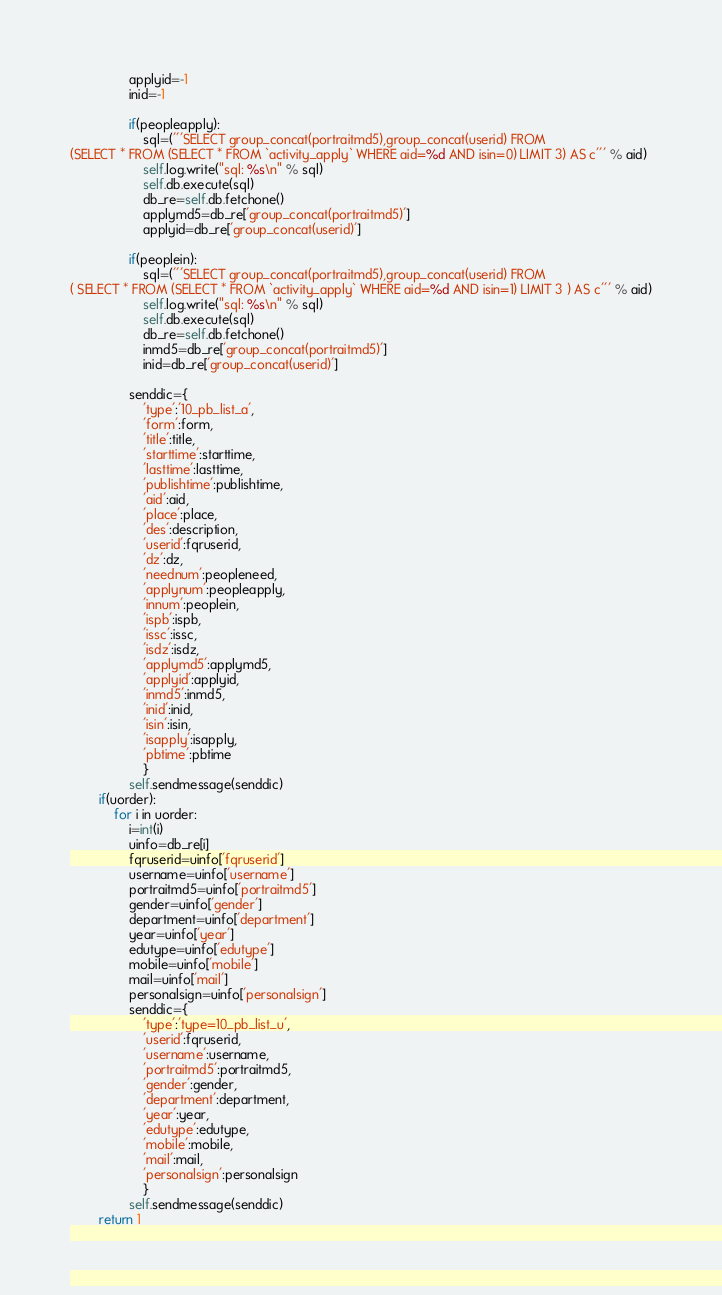Convert code to text. <code><loc_0><loc_0><loc_500><loc_500><_Python_>                applyid=-1
                inid=-1

                if(peopleapply):
                    sql=('''SELECT group_concat(portraitmd5),group_concat(userid) FROM 
(SELECT * FROM (SELECT * FROM `activity_apply` WHERE aid=%d AND isin=0) LIMIT 3) AS c''' % aid)
                    self.log.write("sql: %s\n" % sql)
                    self.db.execute(sql)
                    db_re=self.db.fetchone()
                    applymd5=db_re['group_concat(portraitmd5)']
                    applyid=db_re['group_concat(userid)']

                if(peoplein):
                    sql=('''SELECT group_concat(portraitmd5),group_concat(userid) FROM 
( SELECT * FROM (SELECT * FROM `activity_apply` WHERE aid=%d AND isin=1) LIMIT 3 ) AS c''' % aid)
                    self.log.write("sql: %s\n" % sql)
                    self.db.execute(sql)
                    db_re=self.db.fetchone()
                    inmd5=db_re['group_concat(portraitmd5)']
                    inid=db_re['group_concat(userid)']

                senddic={
                    'type':'10_pb_list_a',
                    'form':form,
                    'title':title,
                    'starttime':starttime,
                    'lasttime':lasttime,
                    'publishtime':publishtime,
                    'aid':aid,
                    'place':place,
                    'des':description,
                    'userid':fqruserid,
                    'dz':dz,
                    'neednum':peopleneed,
                    'applynum':peopleapply,
                    'innum':peoplein,
                    'ispb':ispb,
                    'issc':issc,
                    'isdz':isdz,
                    'applymd5':applymd5,
                    'applyid':applyid,
                    'inmd5':inmd5,
                    'inid':inid,
                    'isin':isin,
                    'isapply':isapply,
                    'pbtime':pbtime
                    }  
                self.sendmessage(senddic)
        if(uorder):
            for i in uorder:
                i=int(i)
                uinfo=db_re[i]
                fqruserid=uinfo['fqruserid']
                username=uinfo['username']
                portraitmd5=uinfo['portraitmd5']
                gender=uinfo['gender']
                department=uinfo['department']
                year=uinfo['year']
                edutype=uinfo['edutype']
                mobile=uinfo['mobile']
                mail=uinfo['mail']
                personalsign=uinfo['personalsign']
                senddic={
                    'type':'type=10_pb_list_u',
                    'userid':fqruserid,
                    'username':username,
                    'portraitmd5':portraitmd5,
                    'gender':gender,
                    'department':department,
                    'year':year,
                    'edutype':edutype,
                    'mobile':mobile,
                    'mail':mail,
                    'personalsign':personalsign
                    }
                self.sendmessage(senddic)
        return 1
</code> 